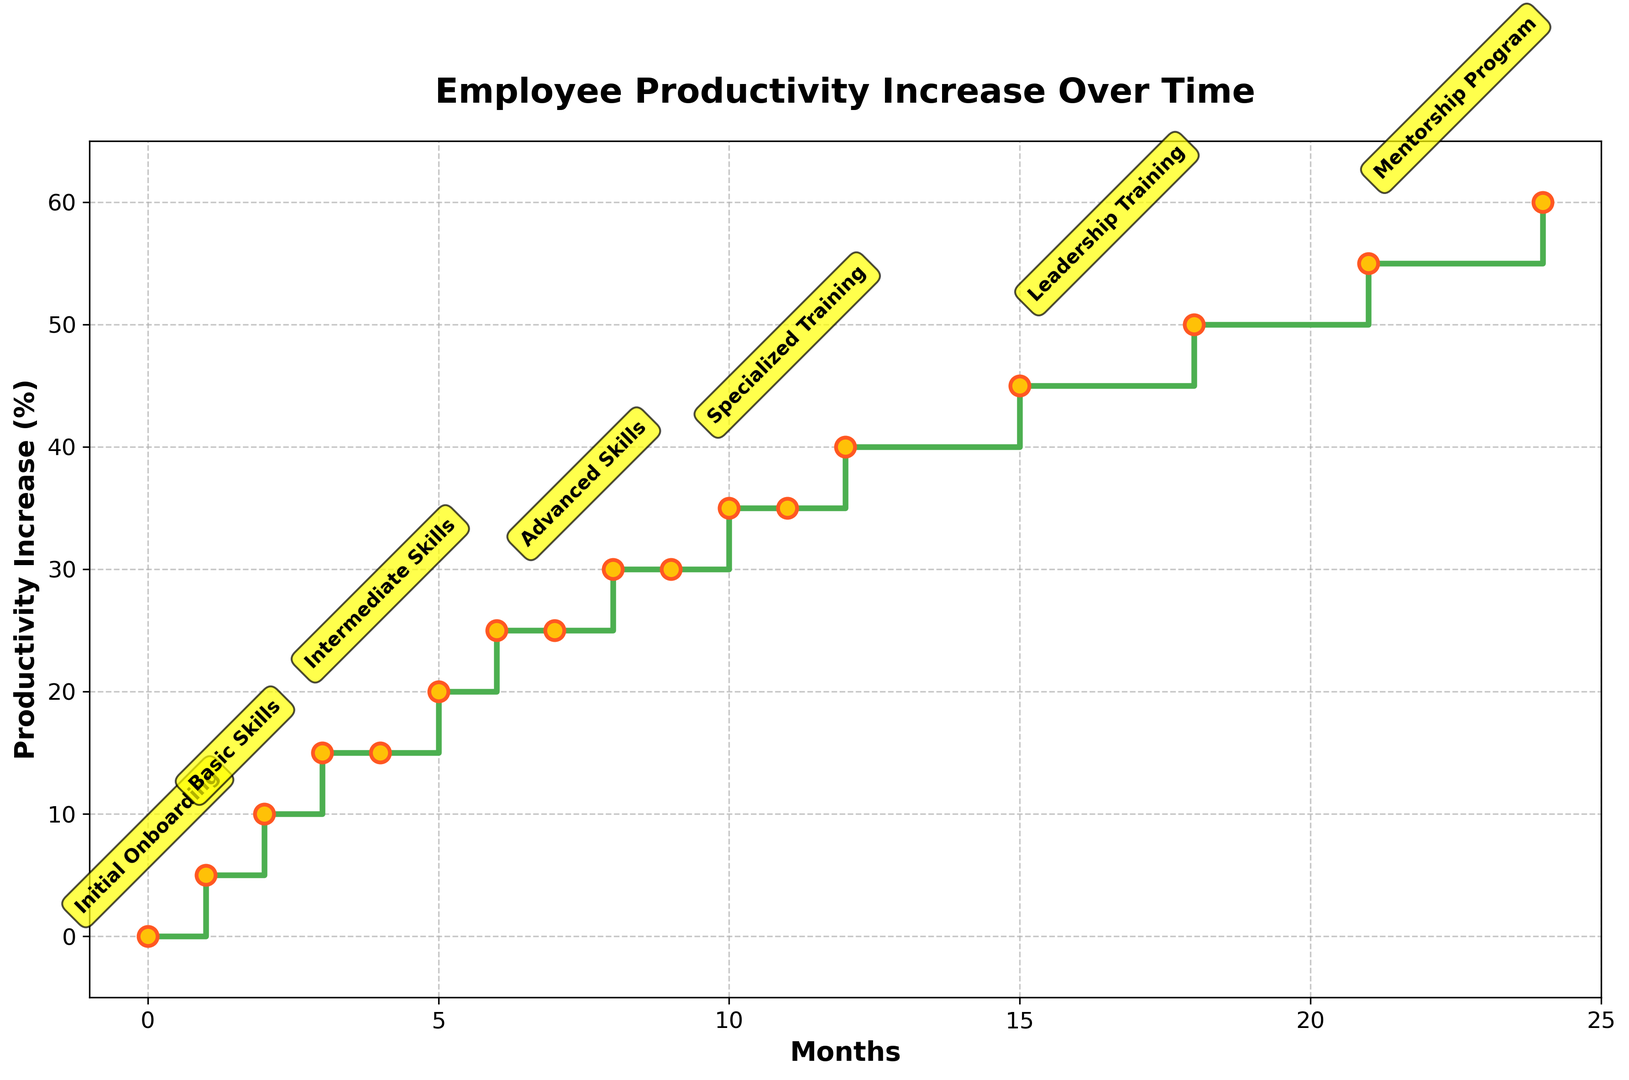How does employee productivity change between the "Intermediate Skills" and "Advanced Skills" training stages? Between the "Intermediate Skills" training stage, which ends at month 5 with a productivity increase of 20%, and the "Advanced Skills" training stage, which starts at month 6 and ends at month 9 with a productivity increase of 30%, the productivity increase rises by 10%.
Answer: Increases by 10% During which training stage does productivity increase the most in a single month? Comparing all training stages visually, productivity increases the most during the "Basic Skills" stage, where it rises from 5% to 10% between month 2 and month 3.
Answer: Basic Skills By how much does productivity increase between the "Specialized Training" and "Leadership Training" stages? The "Specialized Training" stage ends at month 12 with a productivity increase of 40%. The "Leadership Training" stage ends at month 18 with a productivity increase of 50%. The increase is 50% - 40% = 10%.
Answer: 10% Which training stage has the longest duration? "Mentorship Program" stage lasts from month 21 to month 24, which is longer compared to other training stages. "Mentorship Program" stage has the longest duration of 3 months.
Answer: Mentorship Program Which two training stages have no increase in productivity during their entire duration? Both "Intermediate Skills" and "Advanced Skills" stages show flat sections on the stairs plot, indicating no increase in productivity; "Intermediate Skills" from months 3 to 5, and "Advanced Skills" from months 6 to 7 and months 9 to 10.
Answer: Intermediate Skills and Advanced Skills How does the productivity change from the start of the "Basic Skills" to the end of "Specialized Training" training stages? The productivity at the start of "Basic Skills" (month 1) is 5%, and at the end of "Specialized Training" (month 12) is 40%. Therefore, the productivity increase is 40% - 5% = 35%.
Answer: 35% In which month does the productivity increase stop rising during the "Leadership Training" stage? The "Leadership Training" stage shows a productivity increase until month 18, where it remains constant until the next training stage.
Answer: Month 18 Which stage has the highest productivity increase at its completion? The "Mentorship Program" stage has the highest productivity increase, ending at 60% in month 24.
Answer: Mentorship Program What is the total increase in productivity from the start of the plot to the end? The plot starts at month 0 with 0% productivity increase and ends at month 24 with 60%, so the total increase is 60% - 0% = 60%.
Answer: 60% Compare the productivity increase during the "Intermediate Skills" stage and the "Leadership Training" stage. The "Intermediate Skills" stage sees an increase from 15% (month 3) to 20% (month 5), an increase of 5%. The "Leadership Training" stage sees an increase from 40% (month 12) to 50% (month 18), an increase of 10%. Therefore, "Leadership Training" has a higher increase.
Answer: Leadership Training 